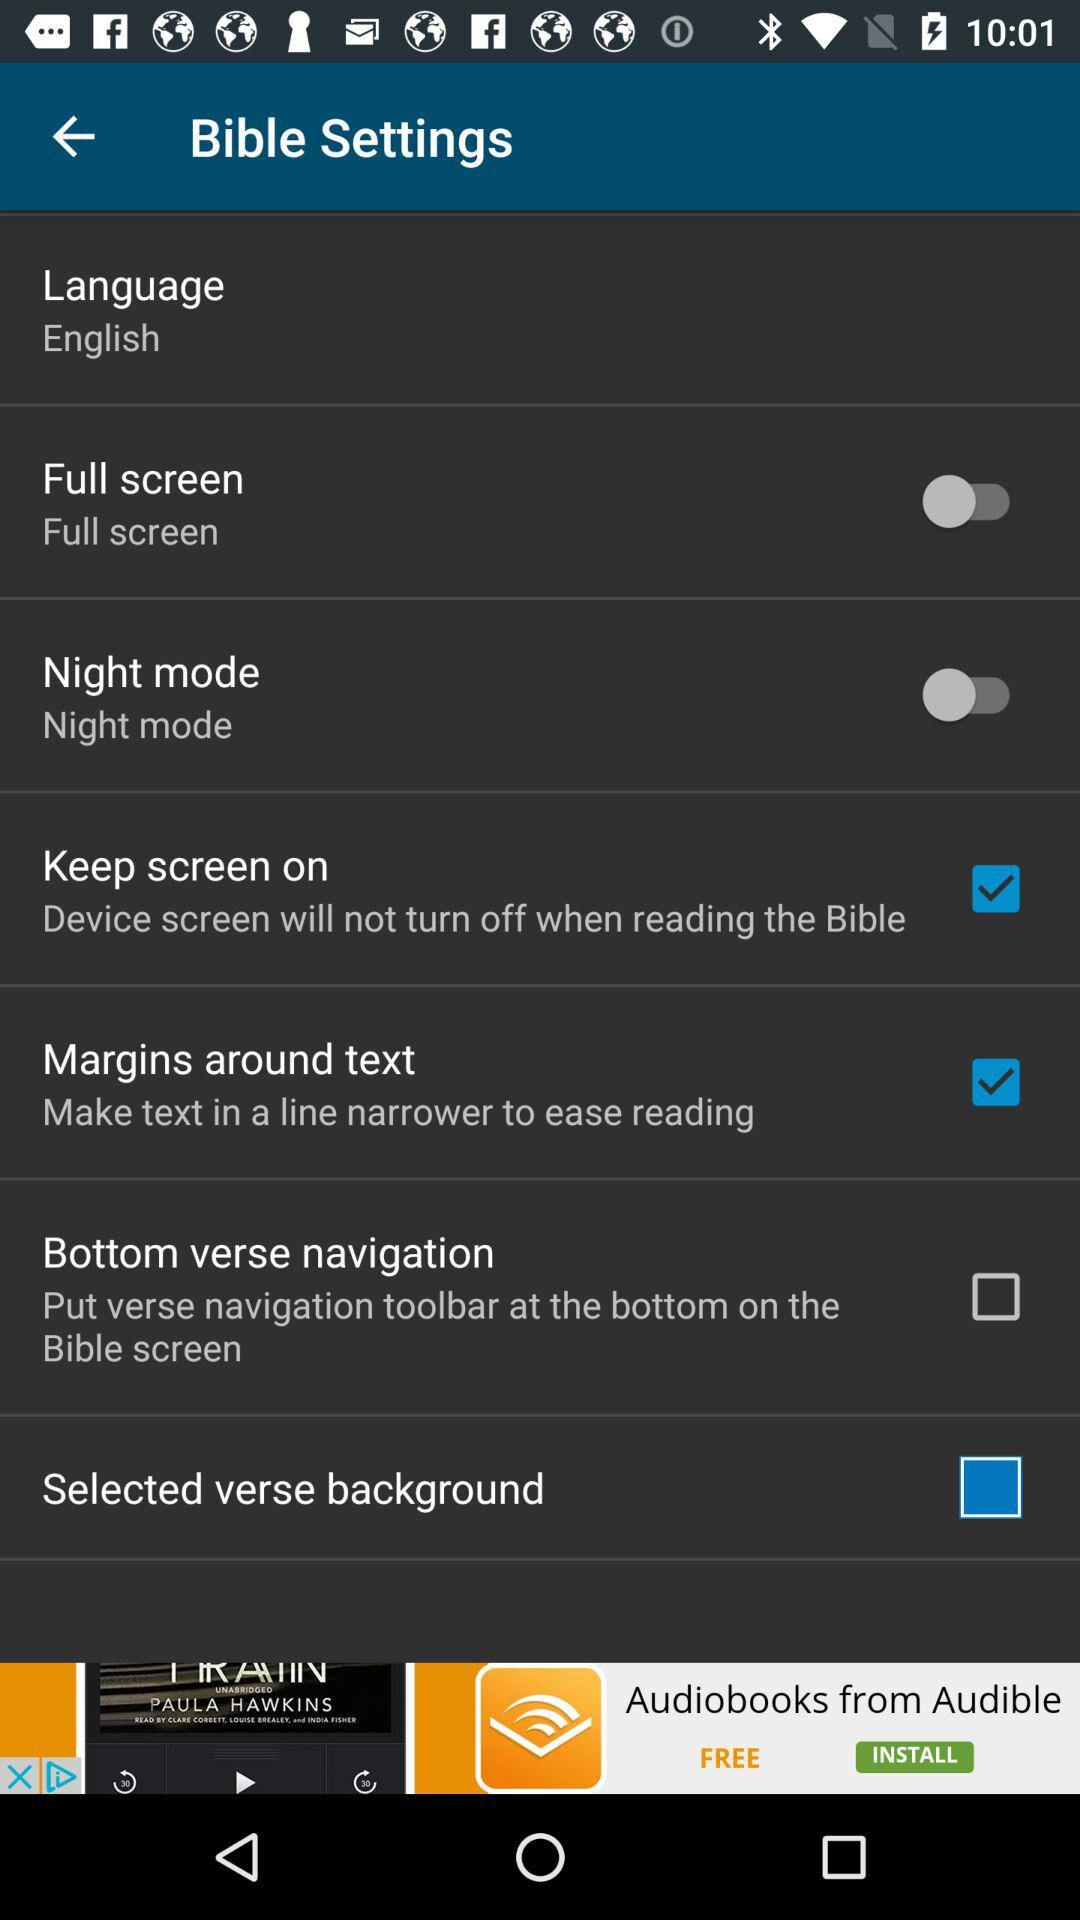What is the status of "Night mode"? The status of "Night mode" is "off". 